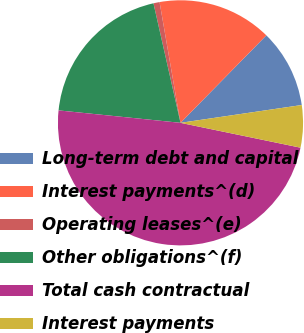Convert chart to OTSL. <chart><loc_0><loc_0><loc_500><loc_500><pie_chart><fcel>Long-term debt and capital<fcel>Interest payments^(d)<fcel>Operating leases^(e)<fcel>Other obligations^(f)<fcel>Total cash contractual<fcel>Interest payments<nl><fcel>10.33%<fcel>15.08%<fcel>0.81%<fcel>19.84%<fcel>48.37%<fcel>5.57%<nl></chart> 